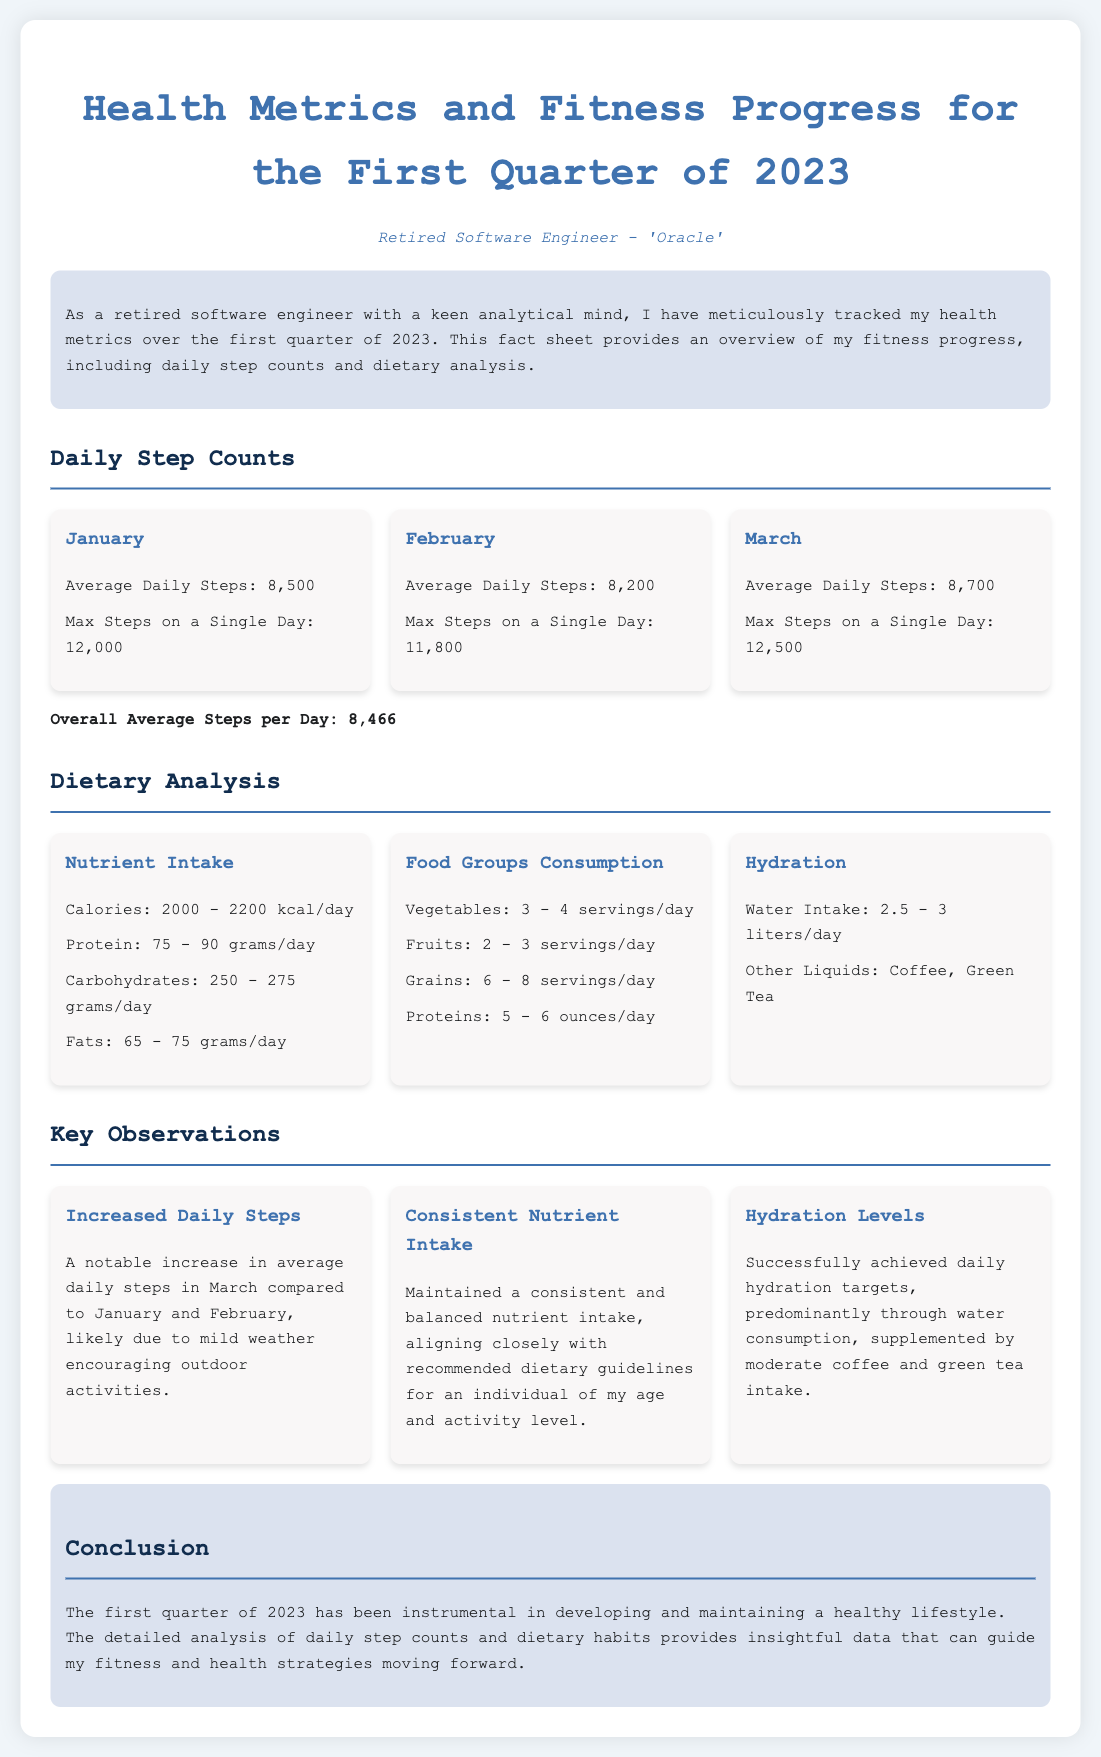What is the average daily steps in January? The average daily steps in January is stated in the document as 8,500.
Answer: 8,500 What was the maximum step count in March? The document mentions that the maximum step count in March was 12,500 steps.
Answer: 12,500 How many servings of vegetables were consumed per day? The fact sheet lists the vegetable consumption as 3 - 4 servings/day.
Answer: 3 - 4 servings What is the overall average steps per day for Q1 2023? The overall average steps calculated in the document is 8,466 steps.
Answer: 8,466 What is the water intake recommendation? The document recommends a water intake of 2.5 - 3 liters/day.
Answer: 2.5 - 3 liters In which month was there a notable increase in average daily steps? The document indicates that March saw a notable increase in average daily steps compared to the earlier months.
Answer: March How does the nutrient intake align with dietary guidelines? The fact sheet notes that the nutrient intake was consistent and aligned closely with recommended dietary guidelines.
Answer: Consistent and aligned What is the general conclusion drawn about Q1 2023? The conclusion highlights the importance of the first quarter in developing and maintaining a healthy lifestyle.
Answer: Instrumental in developing a healthy lifestyle 